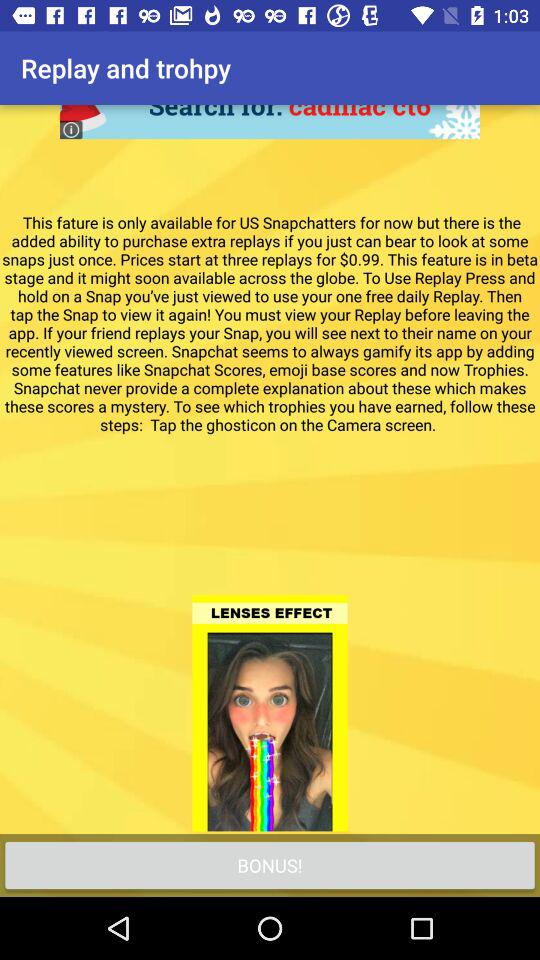Which effect is used in the snap? The effect used in the snap is "LENSES". 